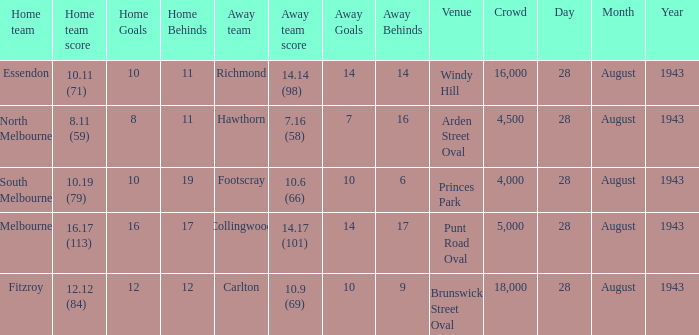Could you parse the entire table? {'header': ['Home team', 'Home team score', 'Home Goals', 'Home Behinds', 'Away team', 'Away team score', 'Away Goals', 'Away Behinds', 'Venue', 'Crowd', 'Day', 'Month', 'Year'], 'rows': [['Essendon', '10.11 (71)', '10', '11', 'Richmond', '14.14 (98)', '14', '14', 'Windy Hill', '16,000', '28', 'August', '1943'], ['North Melbourne', '8.11 (59)', '8', '11', 'Hawthorn', '7.16 (58)', '7', '16', 'Arden Street Oval', '4,500', '28', 'August', '1943'], ['South Melbourne', '10.19 (79)', '10', '19', 'Footscray', '10.6 (66)', '10', '6', 'Princes Park', '4,000', '28', 'August', '1943'], ['Melbourne', '16.17 (113)', '16', '17', 'Collingwood', '14.17 (101)', '14', '17', 'Punt Road Oval', '5,000', '28', 'August', '1943'], ['Fitzroy', '12.12 (84)', '12', '12', 'Carlton', '10.9 (69)', '10', '9', 'Brunswick Street Oval', '18,000', '28', 'August', '1943']]} Where was the game played with an away team score of 14.17 (101)? Punt Road Oval. 